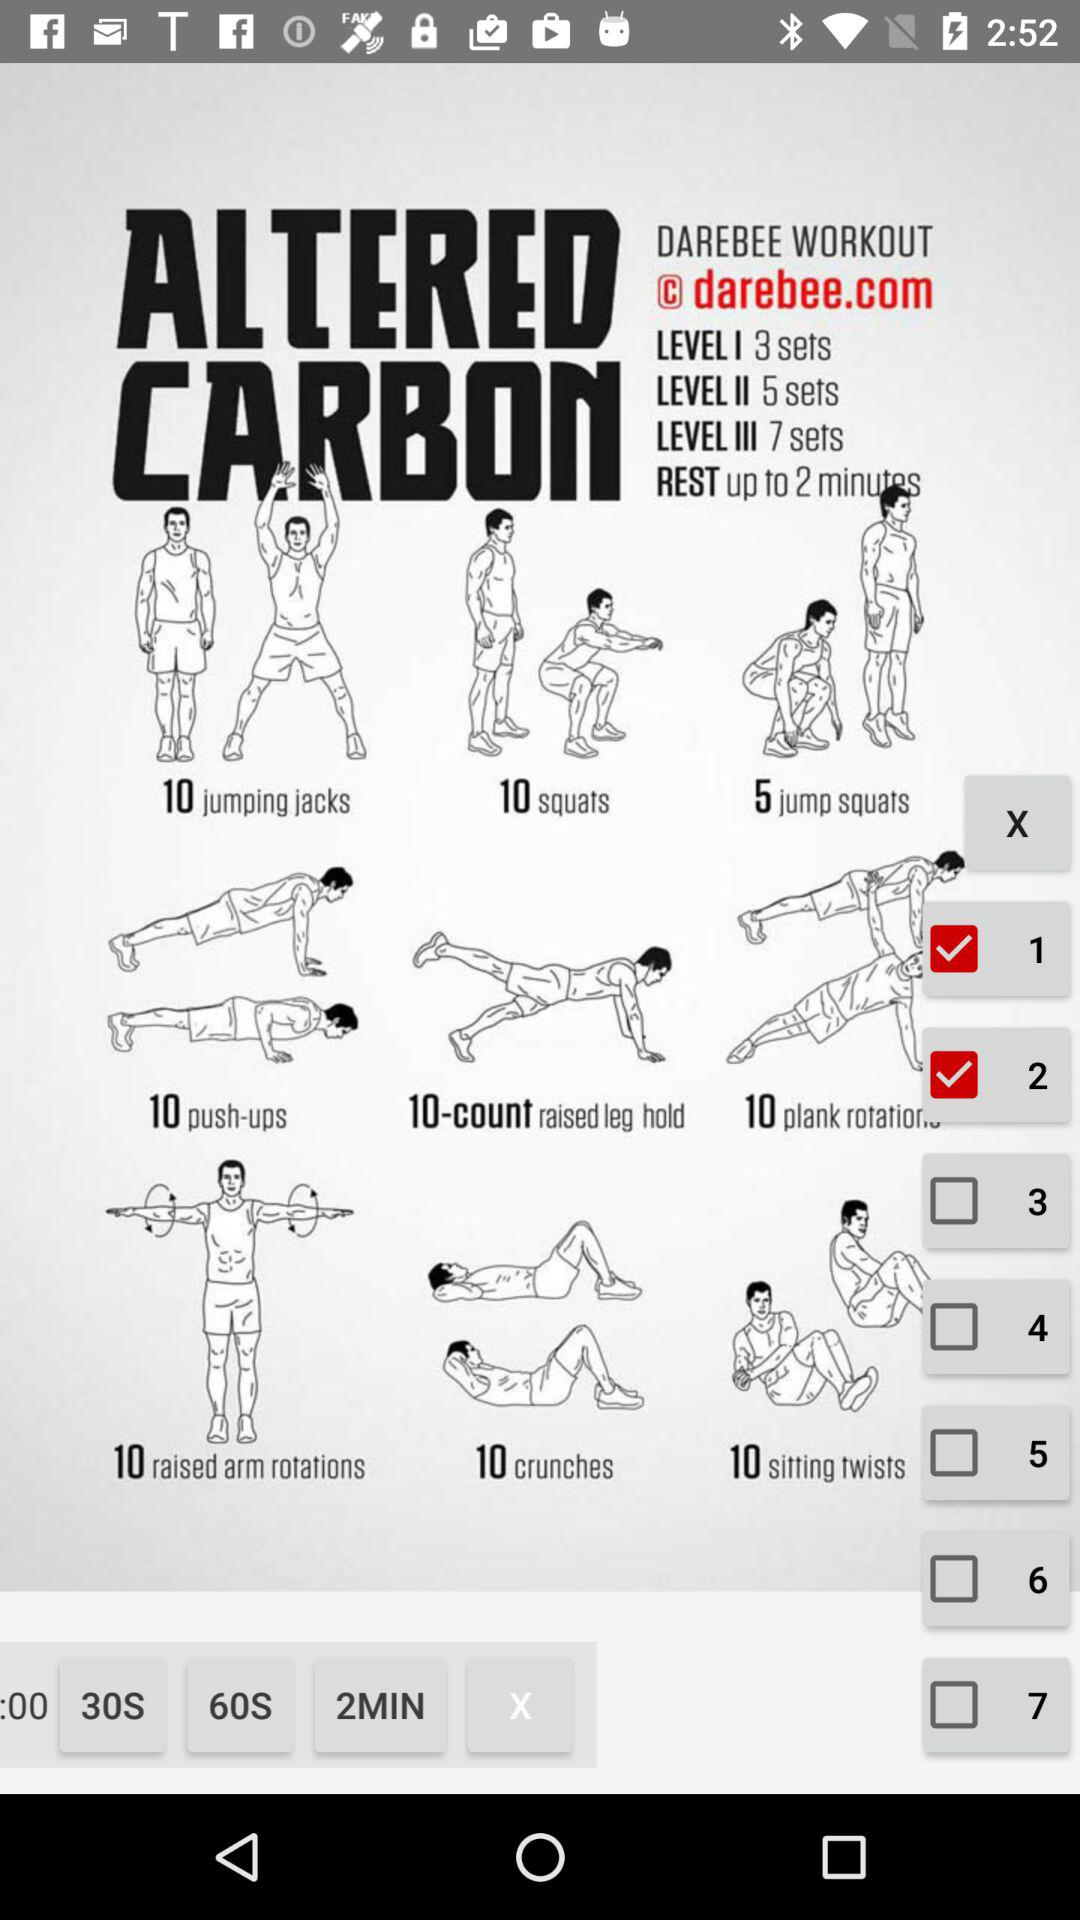How many more sets are in level III than level I?
Answer the question using a single word or phrase. 4 